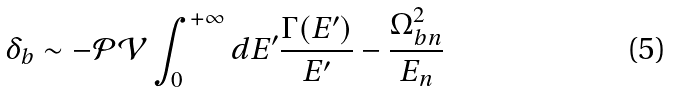Convert formula to latex. <formula><loc_0><loc_0><loc_500><loc_500>\delta _ { b } \sim - \mathcal { P V } \int _ { 0 } ^ { + \infty } d E ^ { \prime } \frac { \Gamma ( E ^ { \prime } ) } { E ^ { \prime } } - \frac { \Omega _ { b n } ^ { 2 } } { E _ { n } }</formula> 